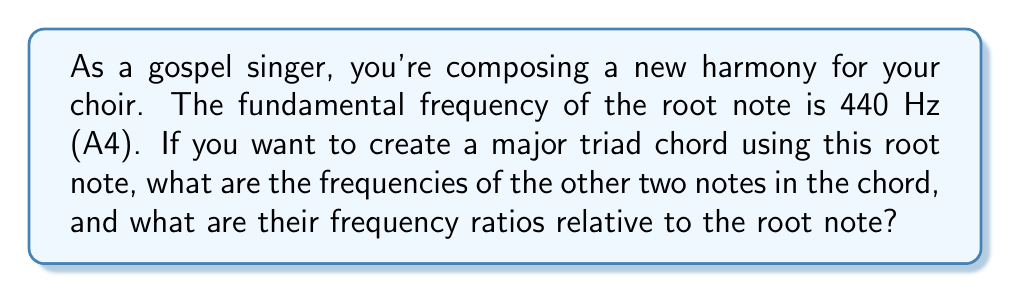Can you answer this question? Let's approach this step-by-step:

1) A major triad chord consists of three notes: the root, the major third, and the perfect fifth.

2) In Western music, the frequency ratios for these intervals are:
   - Root to major third: 5:4
   - Root to perfect fifth: 3:2

3) Given the root note frequency of 440 Hz (A4), we can calculate the other frequencies:

   For the major third:
   $$ f_{major third} = 440 Hz \times \frac{5}{4} = 550 Hz $$

   For the perfect fifth:
   $$ f_{perfect fifth} = 440 Hz \times \frac{3}{2} = 660 Hz $$

4) To express these as frequency ratios relative to the root note:

   Major third: $\frac{550}{440} = \frac{5}{4} = 1.25$
   Perfect fifth: $\frac{660}{440} = \frac{3}{2} = 1.5$

5) Therefore, the frequency ratios of the major triad chord relative to the root note are:
   Root : Major Third : Perfect Fifth = 1 : 1.25 : 1.5
Answer: 550 Hz and 660 Hz; 1 : 1.25 : 1.5 